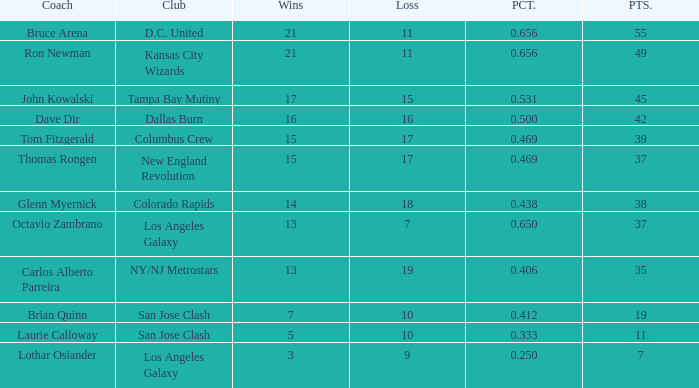When bruce arena loses more than 11 games, what is the highest percentage he reaches? None. 